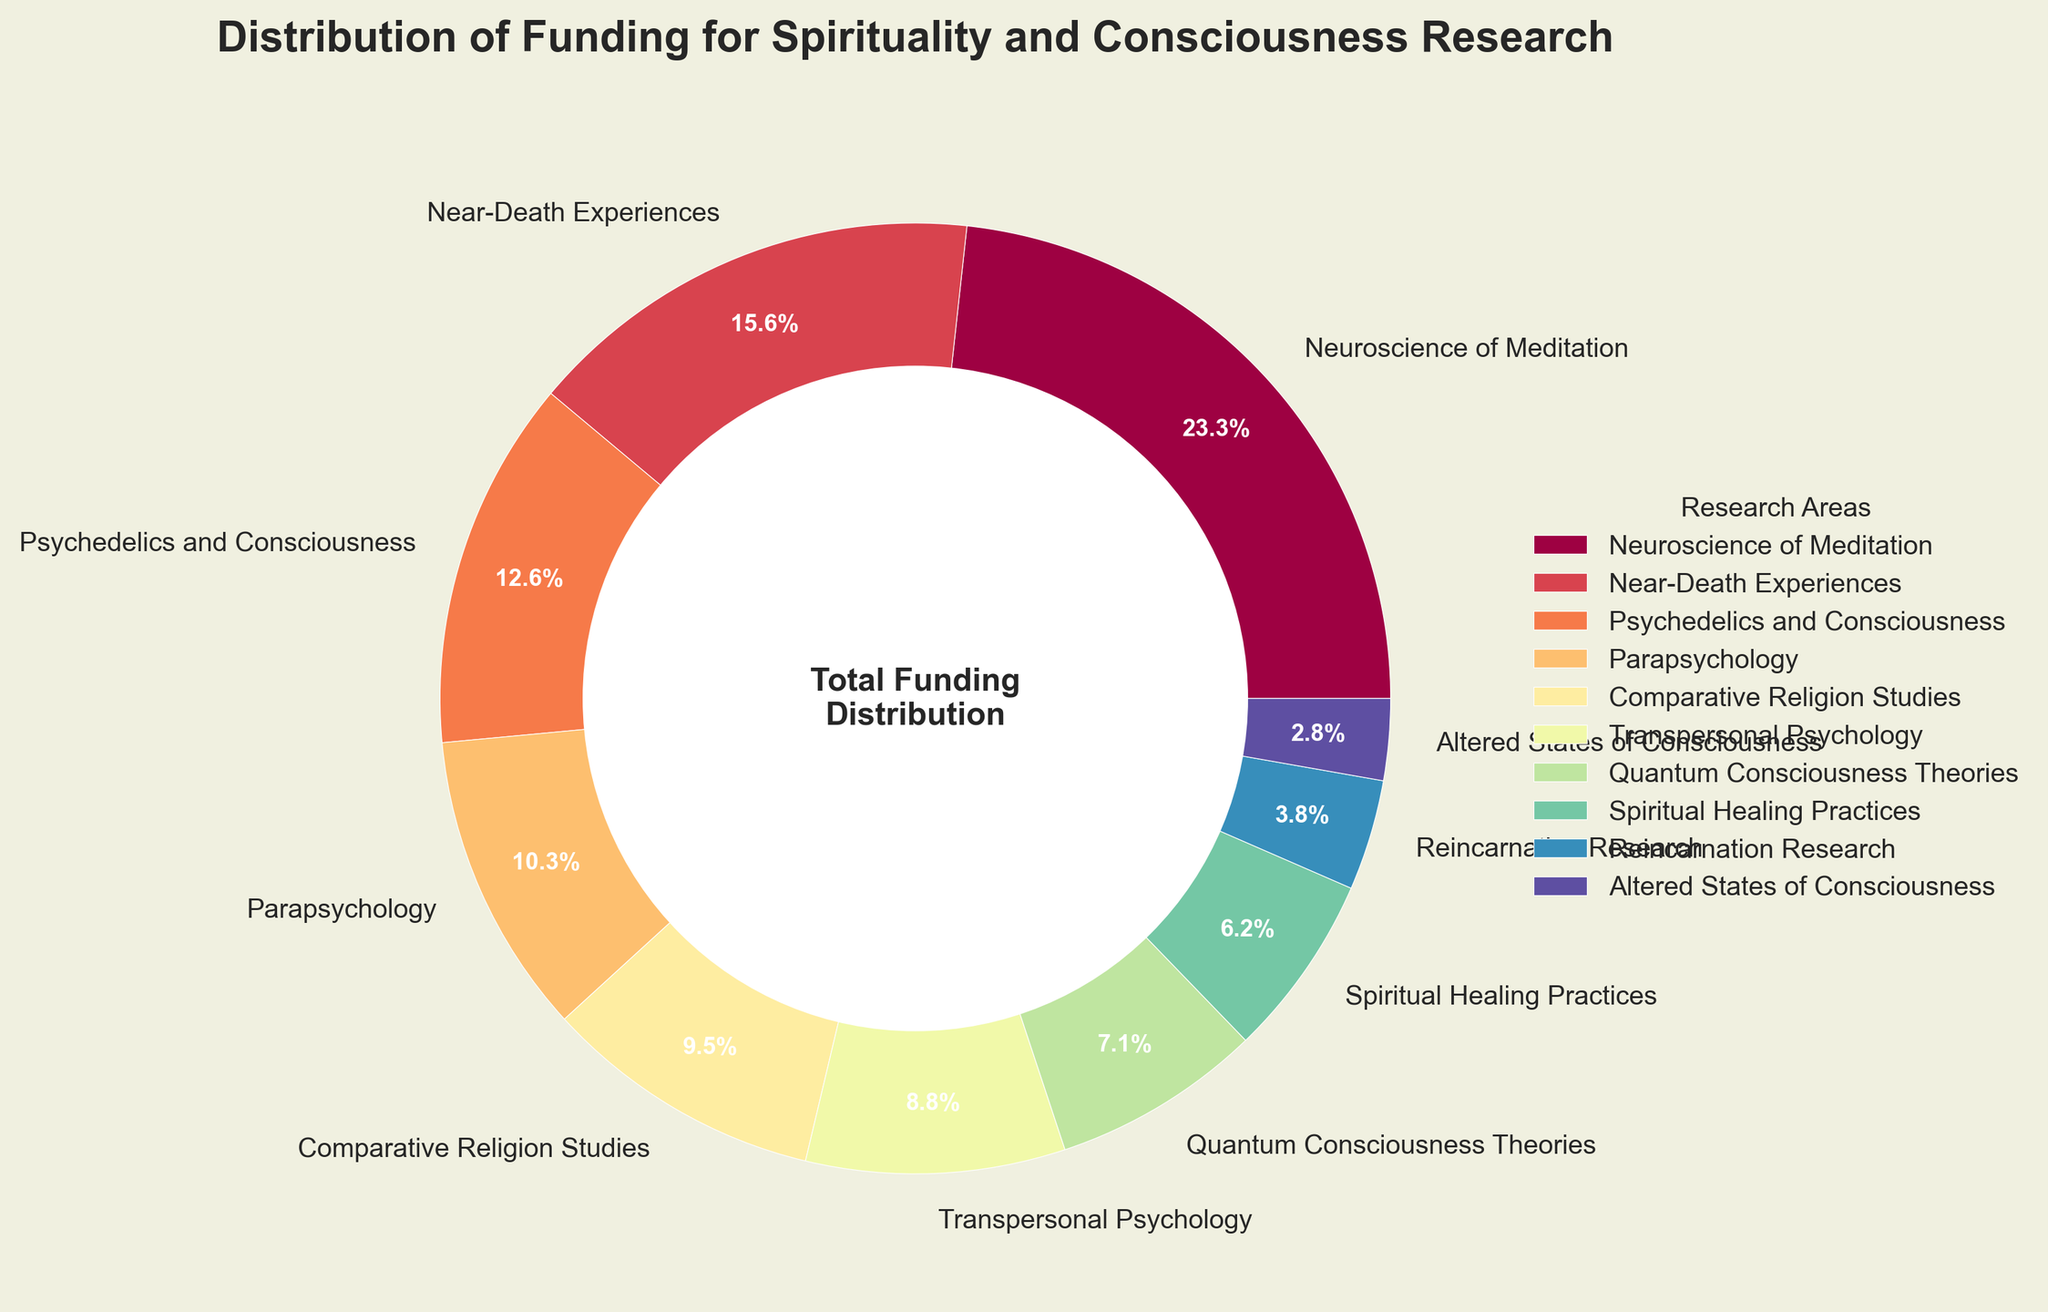Which research area received the most funding? The figure shows that "Neuroscience of Meditation" has the largest wedge in the pie chart. Reading its label shows 23.5%.
Answer: Neuroscience of Meditation What is the total percentage of funding received by Parapsychology and Reincarnation Research combined? The figure provides the funding percentages for Parapsychology (10.4%) and Reincarnation Research (3.8%). Summing these two values gives 10.4% + 3.8% = 14.2%.
Answer: 14.2% How much more funding percentage does Neuroscience of Meditation get compared to Psychedelics and Consciousness? The funding for "Neuroscience of Meditation" is 23.5% and for "Psychedelics and Consciousness" is 12.7%. Subtracting these two values gives 23.5% - 12.7% = 10.8%.
Answer: 10.8% Which research area received the smallest funding? The smallest wedge in the pie chart corresponds to "Altered States of Consciousness," labeled as 2.8%.
Answer: Altered States of Consciousness How many research areas received more than 10% funding each? By examining the pie slices, we can see that "Neuroscience of Meditation" (23.5%), "Near-Death Experiences" (15.8%), and "Psychedelics and Consciousness" (12.7%) are the only areas above 10%.
Answer: 3 Is the funding for Quantum Consciousness Theories larger than for Transpersonal Psychology? The pie chart shows the wedge for "Quantum Consciousness Theories" is labeled with 7.2%, while "Transpersonal Psychology" is labeled with 8.9%. Comparing these values, 7.2% < 8.9%.
Answer: No Which color is used for the highest-funded research area in the pie chart? Analyzing the largest wedge in the pie chart, which represents "Neuroscience of Meditation," reveals it is displayed in a central color from the Spectral colormap scale, which is often yellow or orange in the Spectral palette.
Answer: Yellow/Orange What is the sum of the funding percentages for the four least-funded research areas? The four least-funded research areas are "Reincarnation Research" (3.8%), "Altered States of Consciousness" (2.8%), "Spiritual Healing Practices" (6.3%), and "Quantum Consciousness Theories" (7.2%). Adding these, 3.8% + 2.8% + 6.3% + 7.2% = 20.1%.
Answer: 20.1% Which research area has a funding percentage closest to 10%? From the pie chart, "Parapsychology" with 10.4% is closest to 10%.
Answer: Parapsychology How much funding percentage is allocated to both Comparative Religion Studies and Spiritual Healing Practices? The pie chart shows these respective percentages: "Comparative Religion Studies" (9.6%) and "Spiritual Healing Practices" (6.3%). Adding these, 9.6% + 6.3% = 15.9%.
Answer: 15.9% 